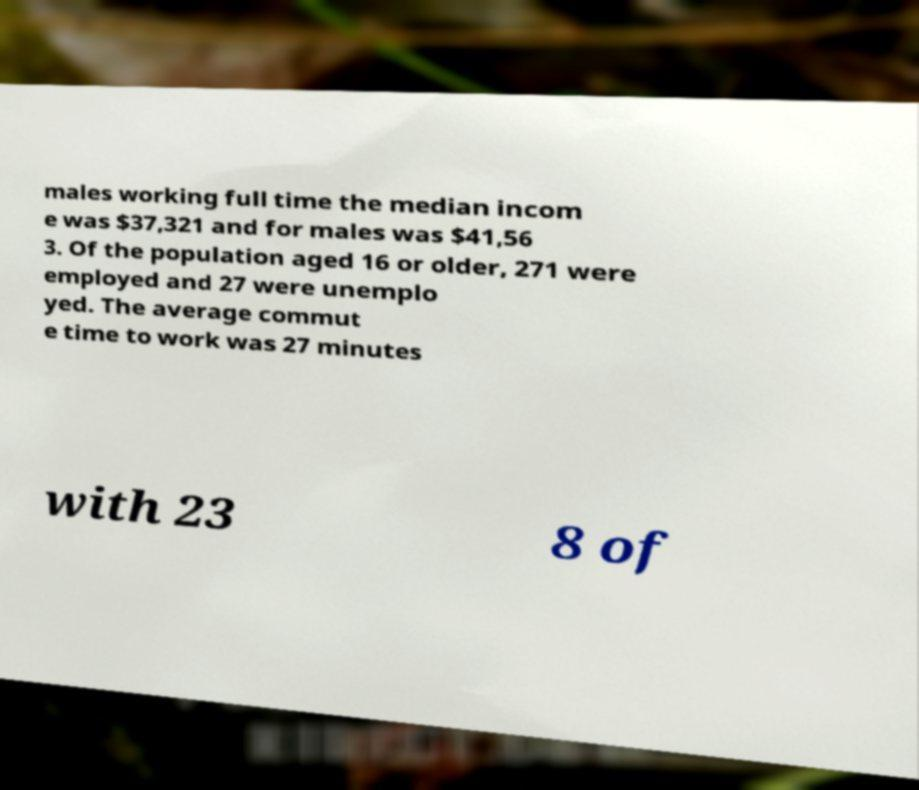What messages or text are displayed in this image? I need them in a readable, typed format. males working full time the median incom e was $37,321 and for males was $41,56 3. Of the population aged 16 or older, 271 were employed and 27 were unemplo yed. The average commut e time to work was 27 minutes with 23 8 of 